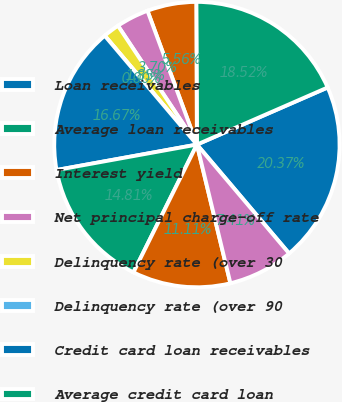Convert chart. <chart><loc_0><loc_0><loc_500><loc_500><pie_chart><fcel>Loan receivables<fcel>Average loan receivables<fcel>Interest yield<fcel>Net principal charge-off rate<fcel>Delinquency rate (over 30<fcel>Delinquency rate (over 90<fcel>Credit card loan receivables<fcel>Average credit card loan<fcel>Personal loan receivables<fcel>Average personal loan<nl><fcel>20.37%<fcel>18.52%<fcel>5.56%<fcel>3.7%<fcel>1.85%<fcel>0.0%<fcel>16.67%<fcel>14.81%<fcel>11.11%<fcel>7.41%<nl></chart> 